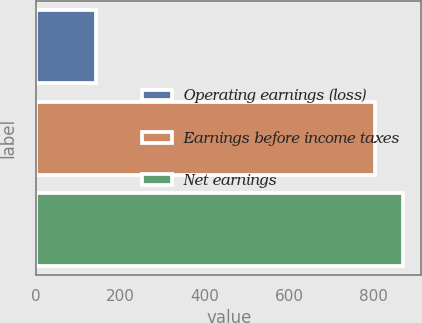Convert chart. <chart><loc_0><loc_0><loc_500><loc_500><bar_chart><fcel>Operating earnings (loss)<fcel>Earnings before income taxes<fcel>Net earnings<nl><fcel>142.4<fcel>804.3<fcel>870.49<nl></chart> 